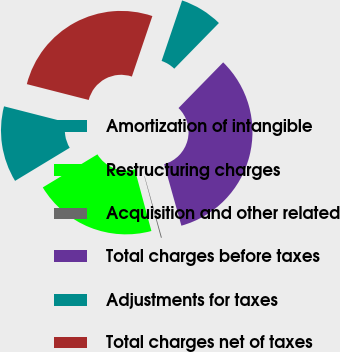Convert chart to OTSL. <chart><loc_0><loc_0><loc_500><loc_500><pie_chart><fcel>Amortization of intangible<fcel>Restructuring charges<fcel>Acquisition and other related<fcel>Total charges before taxes<fcel>Adjustments for taxes<fcel>Total charges net of taxes<nl><fcel>12.65%<fcel>20.53%<fcel>0.15%<fcel>33.33%<fcel>7.12%<fcel>26.21%<nl></chart> 